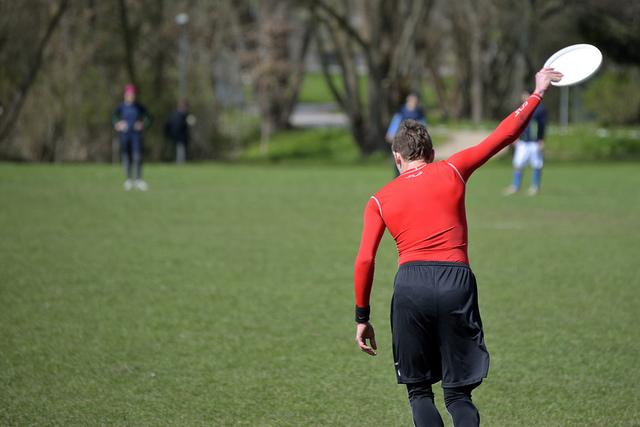How many people are on the field?
Be succinct. 4. What is the person holding?
Give a very brief answer. Frisbee. What color is the man's shirt with the Frisbee?
Give a very brief answer. Red. 